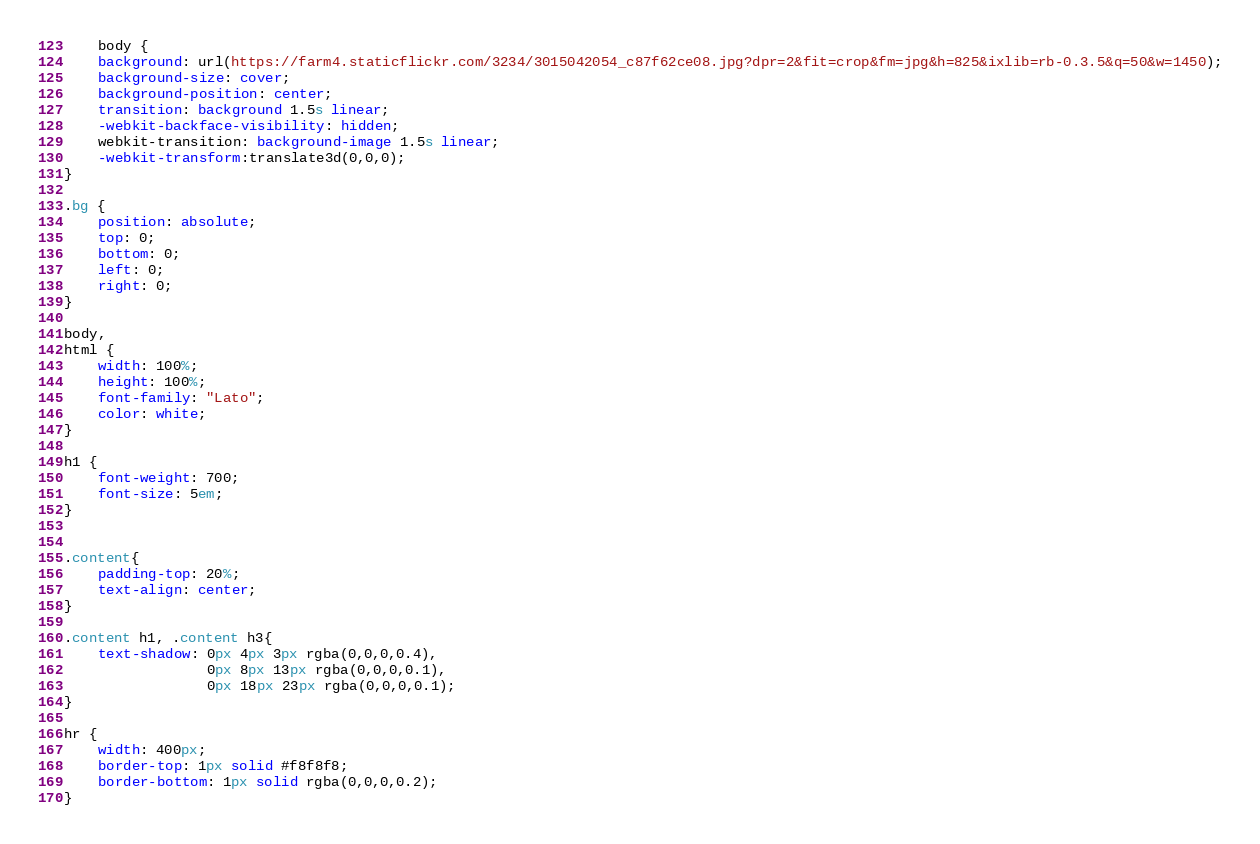Convert code to text. <code><loc_0><loc_0><loc_500><loc_500><_CSS_>    body {
    background: url(https://farm4.staticflickr.com/3234/3015042054_c87f62ce08.jpg?dpr=2&fit=crop&fm=jpg&h=825&ixlib=rb-0.3.5&q=50&w=1450);
    background-size: cover;
    background-position: center; 
    transition: background 1.5s linear;
    -webkit-backface-visibility: hidden;
    webkit-transition: background-image 1.5s linear;
    -webkit-transform:translate3d(0,0,0);
}

.bg {
    position: absolute;
    top: 0;
    bottom: 0;
    left: 0;
    right: 0;
}

body,
html {
    width: 100%;
    height: 100%;
    font-family: "Lato";
    color: white;
}

h1 {
	font-weight: 700;
	font-size: 5em;
}


.content{
	padding-top: 20%;
	text-align: center;
}

.content h1, .content h3{
    text-shadow: 0px 4px 3px rgba(0,0,0,0.4),
                 0px 8px 13px rgba(0,0,0,0.1),
                 0px 18px 23px rgba(0,0,0,0.1);
}

hr {
    width: 400px;
    border-top: 1px solid #f8f8f8;
    border-bottom: 1px solid rgba(0,0,0,0.2);
}
</code> 